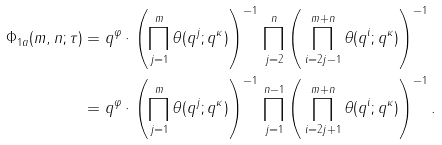Convert formula to latex. <formula><loc_0><loc_0><loc_500><loc_500>\Phi _ { 1 a } ( m , n ; \tau ) & = q ^ { \varphi } \cdot \left ( \prod _ { j = 1 } ^ { m } \theta ( q ^ { j } ; q ^ { \kappa } ) \right ) ^ { - 1 } \, \prod _ { j = 2 } ^ { n } \left ( \, \prod _ { i = 2 j - 1 } ^ { m + n } \theta ( q ^ { i } ; q ^ { \kappa } ) \right ) ^ { - 1 } \\ & = q ^ { \varphi } \cdot \left ( \prod _ { j = 1 } ^ { m } \theta ( q ^ { j } ; q ^ { \kappa } ) \right ) ^ { - 1 } \, \prod _ { j = 1 } ^ { n - 1 } \left ( \, \prod _ { i = 2 j + 1 } ^ { m + n } \theta ( q ^ { i } ; q ^ { \kappa } ) \right ) ^ { - 1 } .</formula> 